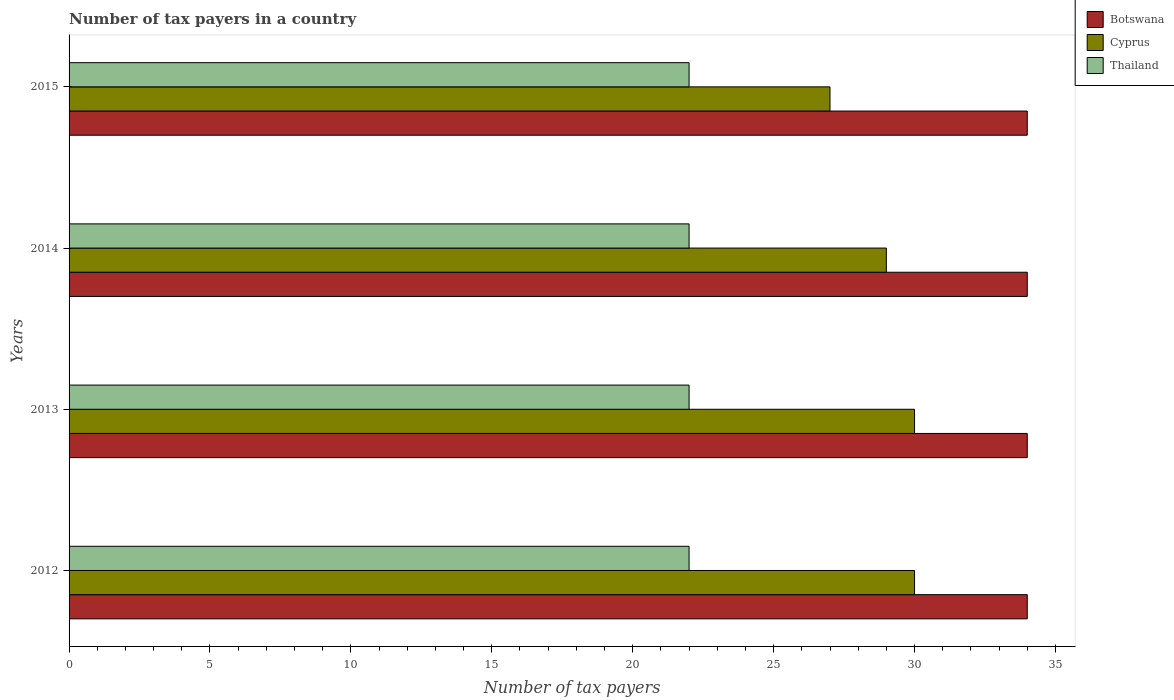How many different coloured bars are there?
Provide a short and direct response. 3. How many groups of bars are there?
Provide a short and direct response. 4. Are the number of bars per tick equal to the number of legend labels?
Provide a succinct answer. Yes. How many bars are there on the 3rd tick from the top?
Provide a short and direct response. 3. What is the number of tax payers in in Cyprus in 2012?
Offer a terse response. 30. Across all years, what is the minimum number of tax payers in in Botswana?
Ensure brevity in your answer.  34. In which year was the number of tax payers in in Cyprus minimum?
Your response must be concise. 2015. What is the total number of tax payers in in Thailand in the graph?
Give a very brief answer. 88. In the year 2013, what is the difference between the number of tax payers in in Botswana and number of tax payers in in Thailand?
Give a very brief answer. 12. In how many years, is the number of tax payers in in Cyprus greater than 21 ?
Your answer should be compact. 4. Is the difference between the number of tax payers in in Botswana in 2014 and 2015 greater than the difference between the number of tax payers in in Thailand in 2014 and 2015?
Keep it short and to the point. No. What is the difference between the highest and the second highest number of tax payers in in Botswana?
Give a very brief answer. 0. In how many years, is the number of tax payers in in Botswana greater than the average number of tax payers in in Botswana taken over all years?
Ensure brevity in your answer.  0. Is the sum of the number of tax payers in in Cyprus in 2014 and 2015 greater than the maximum number of tax payers in in Thailand across all years?
Your answer should be very brief. Yes. What does the 2nd bar from the top in 2014 represents?
Provide a short and direct response. Cyprus. What does the 2nd bar from the bottom in 2014 represents?
Keep it short and to the point. Cyprus. Is it the case that in every year, the sum of the number of tax payers in in Cyprus and number of tax payers in in Botswana is greater than the number of tax payers in in Thailand?
Keep it short and to the point. Yes. What is the difference between two consecutive major ticks on the X-axis?
Give a very brief answer. 5. Does the graph contain any zero values?
Make the answer very short. No. What is the title of the graph?
Provide a short and direct response. Number of tax payers in a country. Does "United Arab Emirates" appear as one of the legend labels in the graph?
Your response must be concise. No. What is the label or title of the X-axis?
Your response must be concise. Number of tax payers. What is the label or title of the Y-axis?
Keep it short and to the point. Years. What is the Number of tax payers of Cyprus in 2012?
Your answer should be compact. 30. What is the Number of tax payers of Cyprus in 2013?
Keep it short and to the point. 30. What is the Number of tax payers of Thailand in 2013?
Give a very brief answer. 22. What is the Number of tax payers in Thailand in 2014?
Ensure brevity in your answer.  22. What is the Number of tax payers in Cyprus in 2015?
Offer a terse response. 27. Across all years, what is the maximum Number of tax payers of Botswana?
Your response must be concise. 34. Across all years, what is the maximum Number of tax payers in Cyprus?
Offer a very short reply. 30. What is the total Number of tax payers of Botswana in the graph?
Your response must be concise. 136. What is the total Number of tax payers of Cyprus in the graph?
Offer a very short reply. 116. What is the total Number of tax payers in Thailand in the graph?
Your response must be concise. 88. What is the difference between the Number of tax payers of Thailand in 2012 and that in 2014?
Ensure brevity in your answer.  0. What is the difference between the Number of tax payers in Cyprus in 2012 and that in 2015?
Provide a succinct answer. 3. What is the difference between the Number of tax payers in Thailand in 2012 and that in 2015?
Offer a very short reply. 0. What is the difference between the Number of tax payers in Cyprus in 2013 and that in 2014?
Offer a terse response. 1. What is the difference between the Number of tax payers in Thailand in 2013 and that in 2014?
Keep it short and to the point. 0. What is the difference between the Number of tax payers in Cyprus in 2014 and that in 2015?
Your response must be concise. 2. What is the difference between the Number of tax payers of Botswana in 2012 and the Number of tax payers of Cyprus in 2013?
Provide a succinct answer. 4. What is the difference between the Number of tax payers of Cyprus in 2012 and the Number of tax payers of Thailand in 2013?
Provide a short and direct response. 8. What is the difference between the Number of tax payers of Botswana in 2012 and the Number of tax payers of Thailand in 2014?
Keep it short and to the point. 12. What is the difference between the Number of tax payers in Botswana in 2012 and the Number of tax payers in Thailand in 2015?
Offer a very short reply. 12. What is the difference between the Number of tax payers in Botswana in 2013 and the Number of tax payers in Thailand in 2014?
Keep it short and to the point. 12. What is the difference between the Number of tax payers in Botswana in 2013 and the Number of tax payers in Cyprus in 2015?
Give a very brief answer. 7. What is the average Number of tax payers of Cyprus per year?
Ensure brevity in your answer.  29. What is the average Number of tax payers in Thailand per year?
Make the answer very short. 22. In the year 2012, what is the difference between the Number of tax payers of Botswana and Number of tax payers of Thailand?
Provide a short and direct response. 12. In the year 2012, what is the difference between the Number of tax payers in Cyprus and Number of tax payers in Thailand?
Offer a very short reply. 8. In the year 2013, what is the difference between the Number of tax payers of Botswana and Number of tax payers of Cyprus?
Keep it short and to the point. 4. In the year 2013, what is the difference between the Number of tax payers in Botswana and Number of tax payers in Thailand?
Ensure brevity in your answer.  12. In the year 2013, what is the difference between the Number of tax payers in Cyprus and Number of tax payers in Thailand?
Your answer should be very brief. 8. What is the ratio of the Number of tax payers of Botswana in 2012 to that in 2013?
Your response must be concise. 1. What is the ratio of the Number of tax payers in Cyprus in 2012 to that in 2013?
Your answer should be compact. 1. What is the ratio of the Number of tax payers in Botswana in 2012 to that in 2014?
Provide a succinct answer. 1. What is the ratio of the Number of tax payers of Cyprus in 2012 to that in 2014?
Your response must be concise. 1.03. What is the ratio of the Number of tax payers of Botswana in 2012 to that in 2015?
Offer a terse response. 1. What is the ratio of the Number of tax payers in Botswana in 2013 to that in 2014?
Your answer should be compact. 1. What is the ratio of the Number of tax payers of Cyprus in 2013 to that in 2014?
Your answer should be compact. 1.03. What is the ratio of the Number of tax payers in Cyprus in 2013 to that in 2015?
Provide a succinct answer. 1.11. What is the ratio of the Number of tax payers of Thailand in 2013 to that in 2015?
Keep it short and to the point. 1. What is the ratio of the Number of tax payers in Cyprus in 2014 to that in 2015?
Give a very brief answer. 1.07. What is the ratio of the Number of tax payers in Thailand in 2014 to that in 2015?
Provide a succinct answer. 1. What is the difference between the highest and the second highest Number of tax payers of Cyprus?
Keep it short and to the point. 0. What is the difference between the highest and the second highest Number of tax payers of Thailand?
Make the answer very short. 0. 